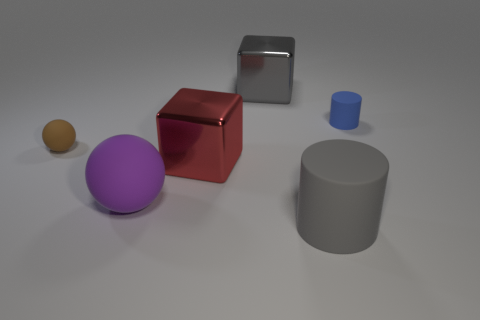How many metallic cubes are the same color as the small cylinder? 0 